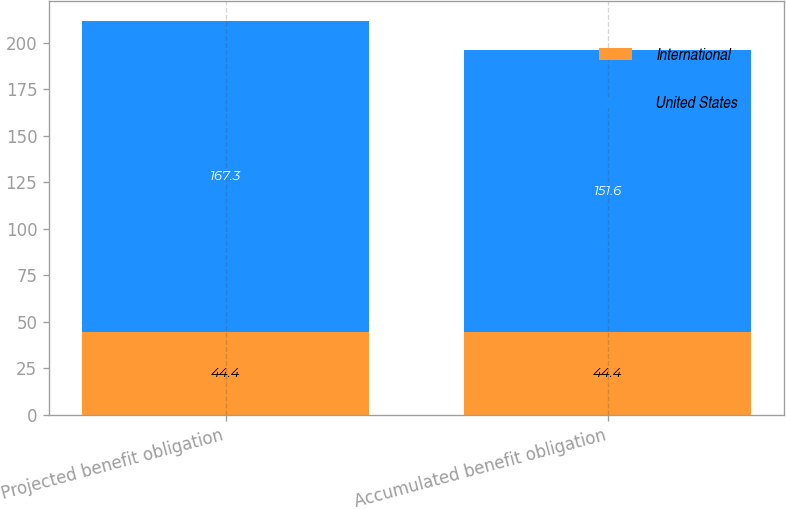<chart> <loc_0><loc_0><loc_500><loc_500><stacked_bar_chart><ecel><fcel>Projected benefit obligation<fcel>Accumulated benefit obligation<nl><fcel>International<fcel>44.4<fcel>44.4<nl><fcel>United States<fcel>167.3<fcel>151.6<nl></chart> 